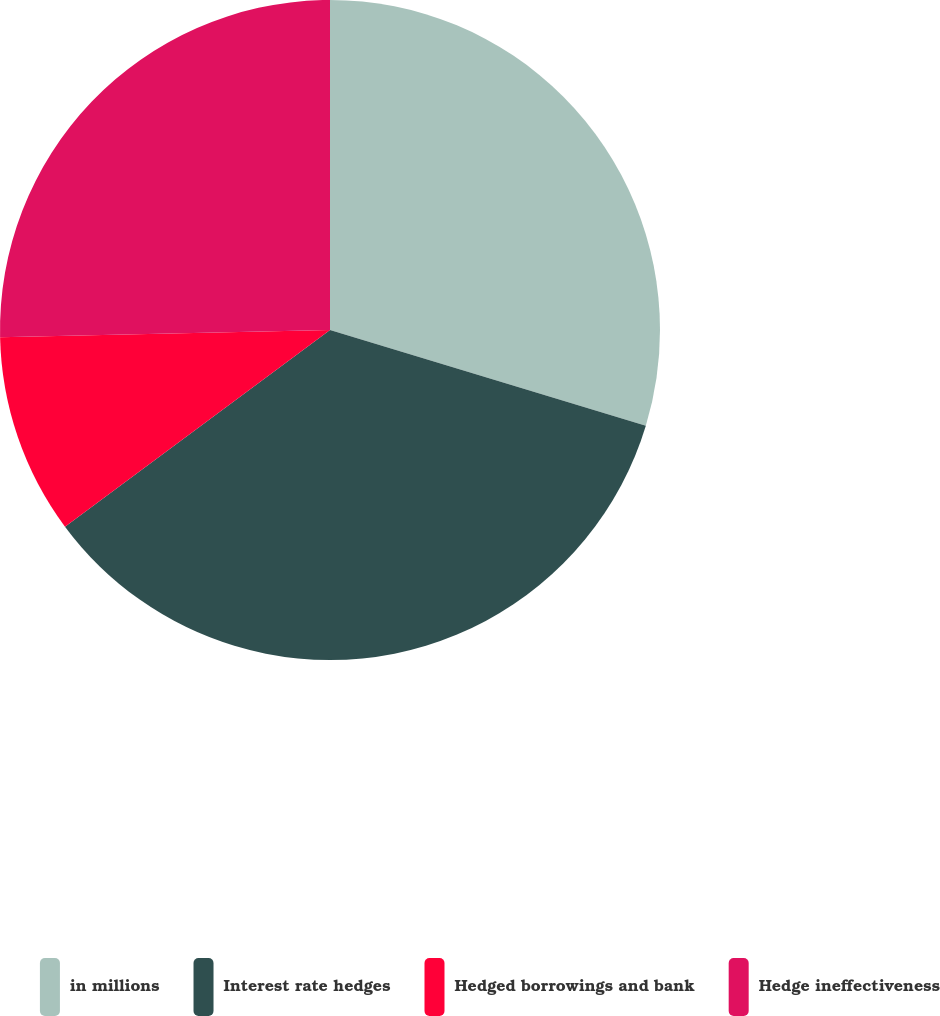Convert chart to OTSL. <chart><loc_0><loc_0><loc_500><loc_500><pie_chart><fcel>in millions<fcel>Interest rate hedges<fcel>Hedged borrowings and bank<fcel>Hedge ineffectiveness<nl><fcel>29.68%<fcel>35.16%<fcel>9.81%<fcel>25.35%<nl></chart> 